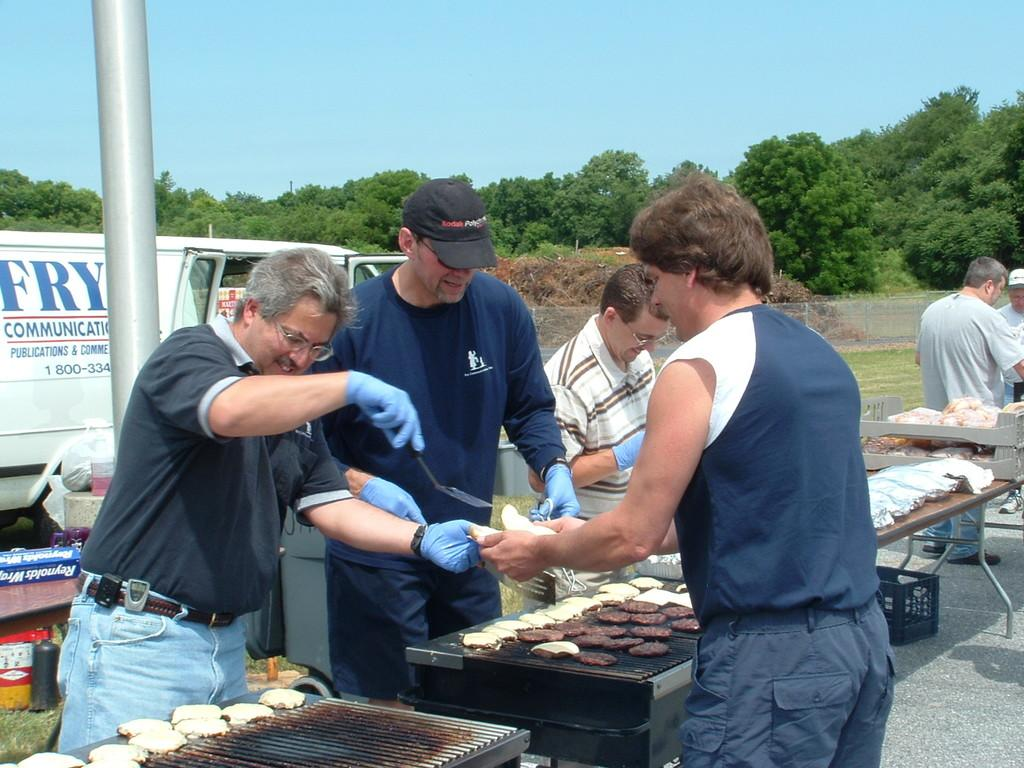What are the people in the image doing? The people in the image are serving food at a table. What can be seen in the background of the image? There is a pole, a vehicle, trees, and the sky visible in the background of the image. What type of toothbrush is being used by the people serving food in the image? There is no toothbrush present in the image. What tax is being discussed by the people serving food in the image? There is no discussion of taxes in the image; the people are focused on serving food. 